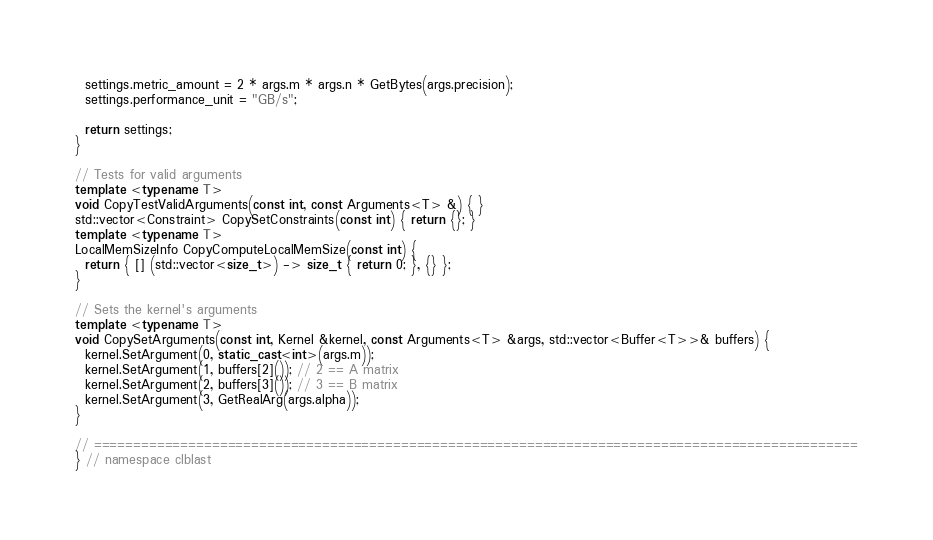<code> <loc_0><loc_0><loc_500><loc_500><_C++_>  settings.metric_amount = 2 * args.m * args.n * GetBytes(args.precision);
  settings.performance_unit = "GB/s";

  return settings;
}

// Tests for valid arguments
template <typename T>
void CopyTestValidArguments(const int, const Arguments<T> &) { }
std::vector<Constraint> CopySetConstraints(const int) { return {}; }
template <typename T>
LocalMemSizeInfo CopyComputeLocalMemSize(const int) {
  return { [] (std::vector<size_t>) -> size_t { return 0; }, {} };
}

// Sets the kernel's arguments
template <typename T>
void CopySetArguments(const int, Kernel &kernel, const Arguments<T> &args, std::vector<Buffer<T>>& buffers) {
  kernel.SetArgument(0, static_cast<int>(args.m));
  kernel.SetArgument(1, buffers[2]()); // 2 == A matrix
  kernel.SetArgument(2, buffers[3]()); // 3 == B matrix
  kernel.SetArgument(3, GetRealArg(args.alpha));
}

// =================================================================================================
} // namespace clblast
</code> 